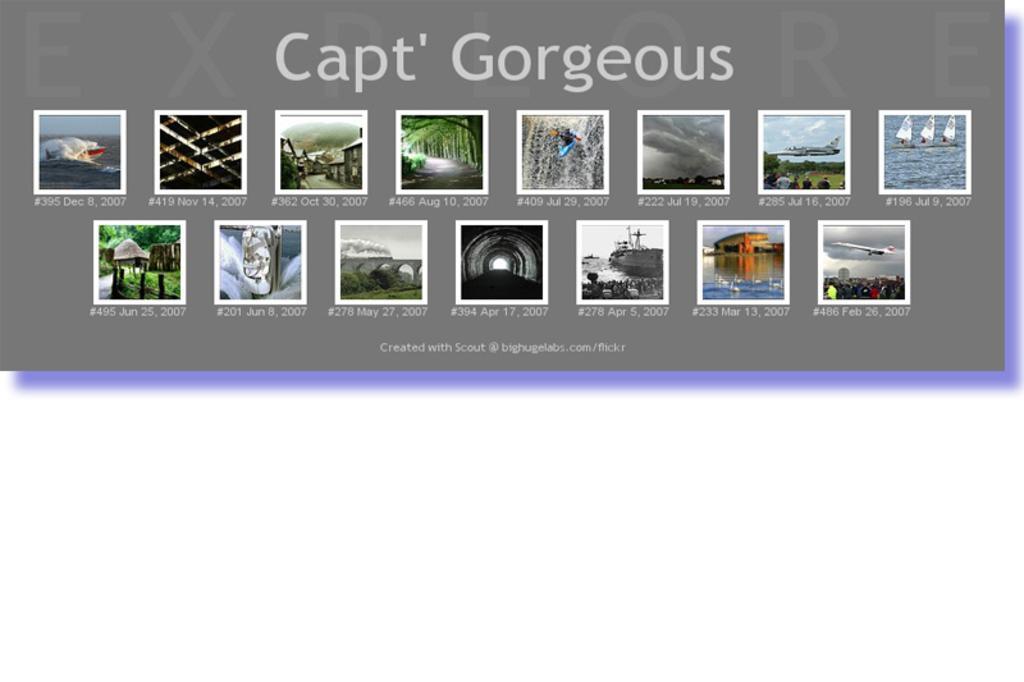Could you give a brief overview of what you see in this image? In this picture we can see many images and text are present on the display screen. 